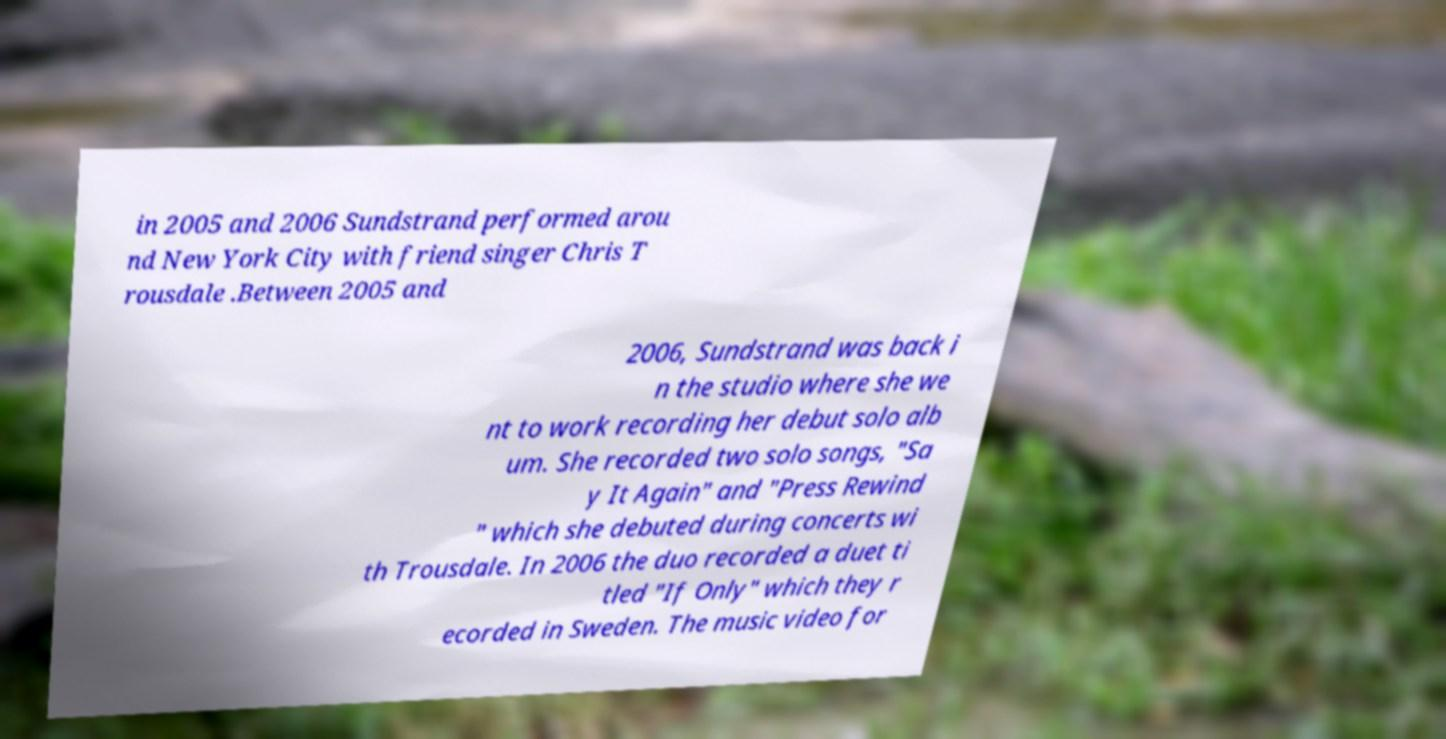Please read and relay the text visible in this image. What does it say? in 2005 and 2006 Sundstrand performed arou nd New York City with friend singer Chris T rousdale .Between 2005 and 2006, Sundstrand was back i n the studio where she we nt to work recording her debut solo alb um. She recorded two solo songs, "Sa y It Again" and "Press Rewind " which she debuted during concerts wi th Trousdale. In 2006 the duo recorded a duet ti tled "If Only" which they r ecorded in Sweden. The music video for 